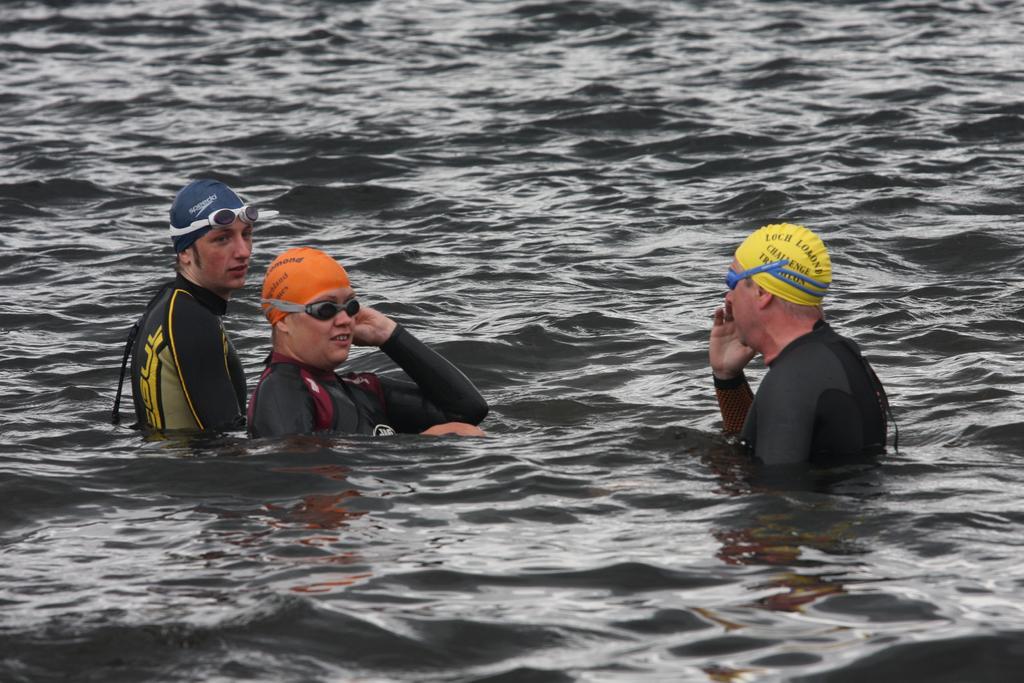Describe this image in one or two sentences. In this image I can see few persons wearing black colored dresses are in the water. I can see they have goggles and caps. In the background I can see the water. 